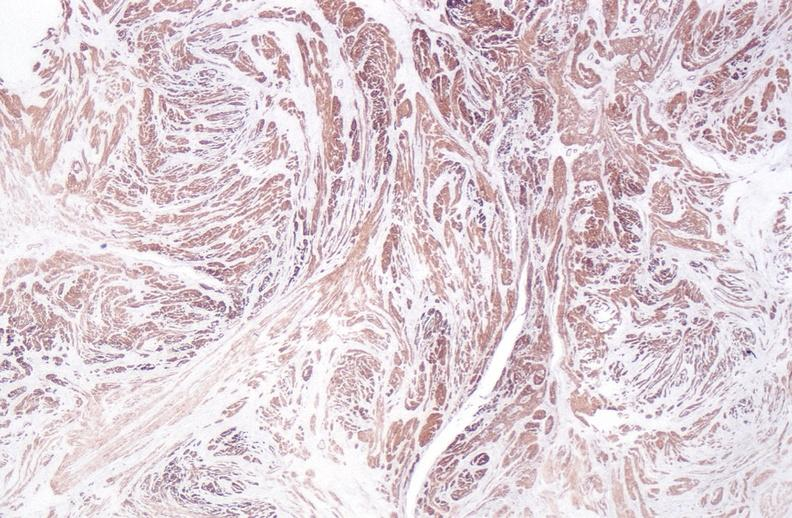what stain?
Answer the question using a single word or phrase. Leiomyoma, alpha smooth muscle actin immunohistochemical 